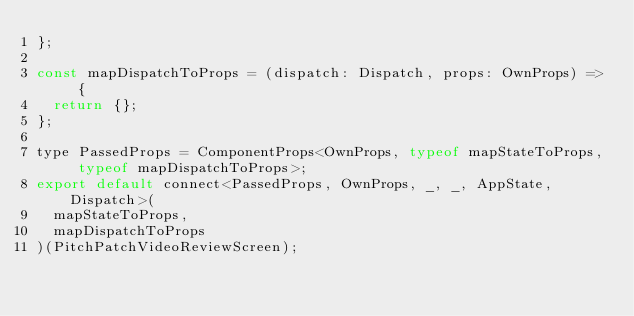Convert code to text. <code><loc_0><loc_0><loc_500><loc_500><_JavaScript_>};

const mapDispatchToProps = (dispatch: Dispatch, props: OwnProps) => {
  return {};
};

type PassedProps = ComponentProps<OwnProps, typeof mapStateToProps, typeof mapDispatchToProps>;
export default connect<PassedProps, OwnProps, _, _, AppState, Dispatch>(
  mapStateToProps,
  mapDispatchToProps
)(PitchPatchVideoReviewScreen);
</code> 